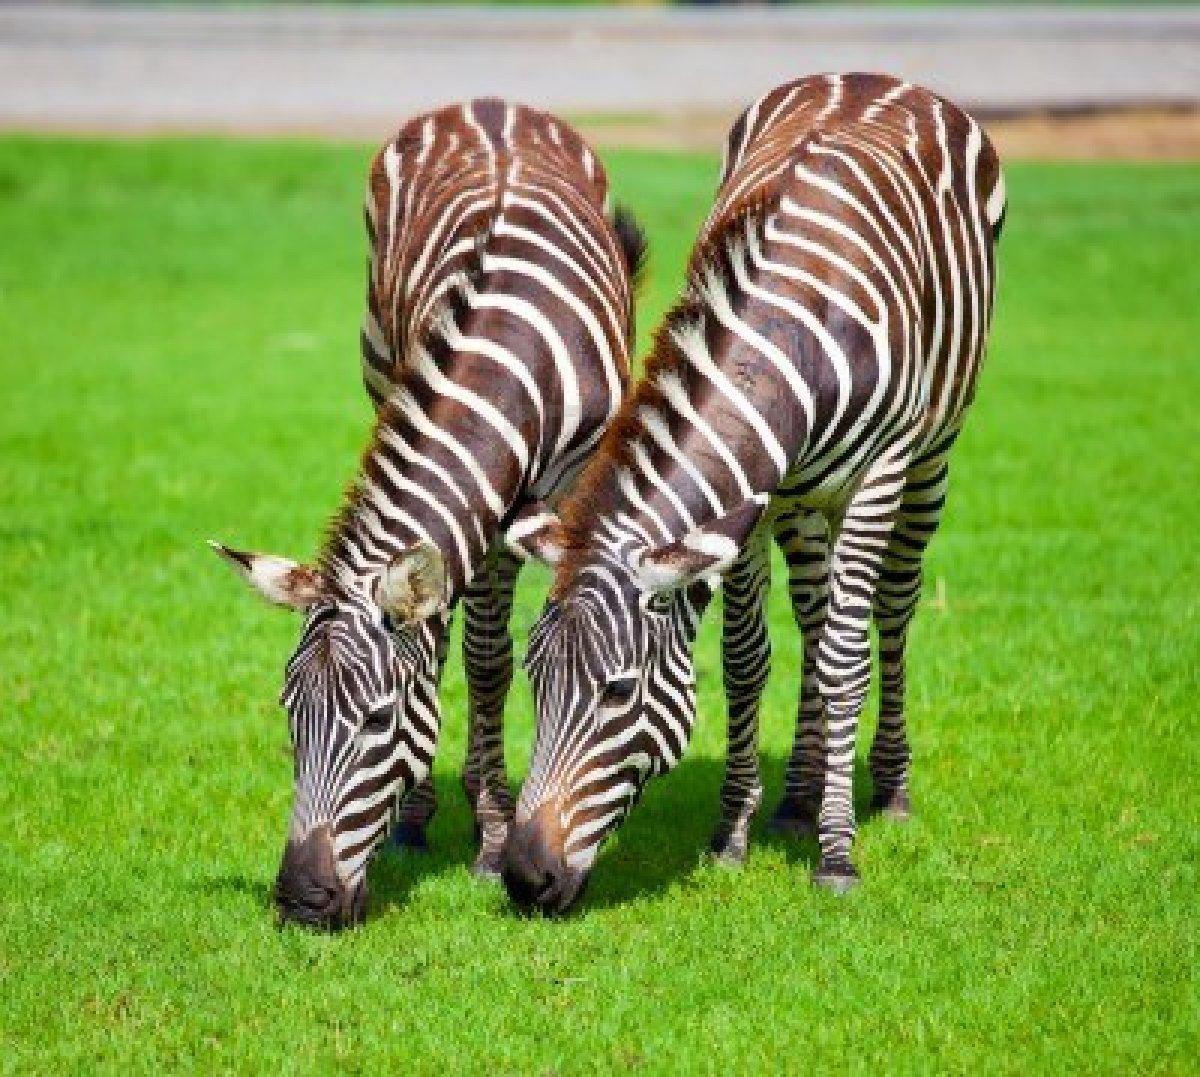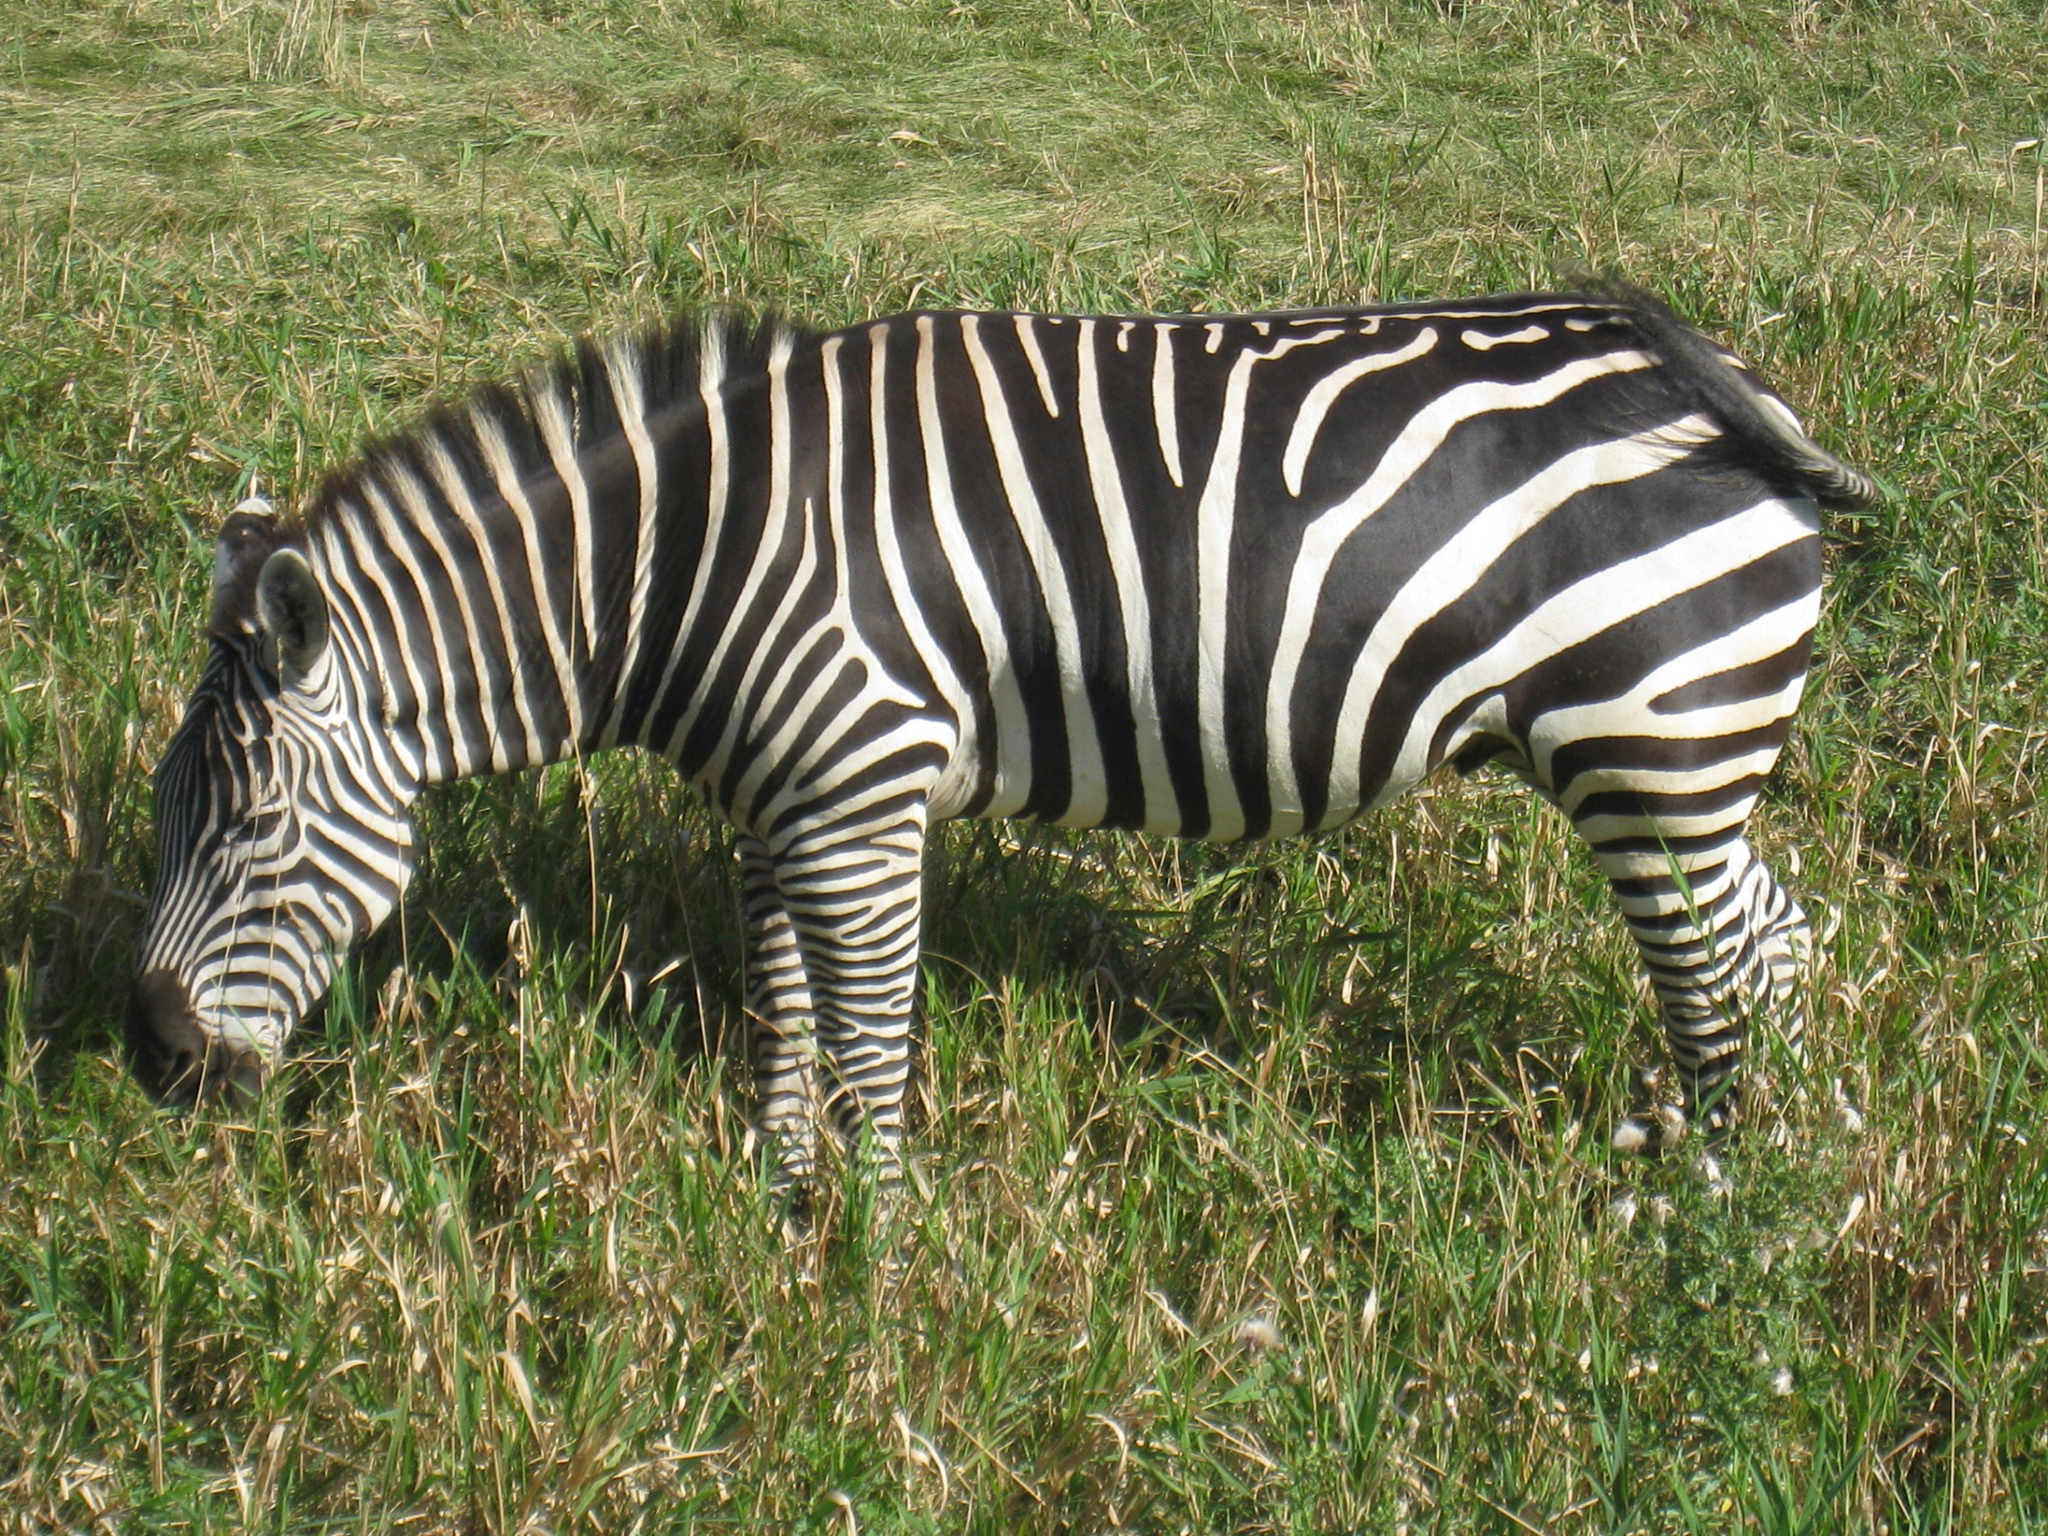The first image is the image on the left, the second image is the image on the right. For the images shown, is this caption "The right image contains one zebra with lowered head and body in profile, and the left image features two zebras side-to-side with bodies parallel." true? Answer yes or no. Yes. The first image is the image on the left, the second image is the image on the right. For the images displayed, is the sentence "Two zebras facing the same way are grazing in the grass." factually correct? Answer yes or no. Yes. 